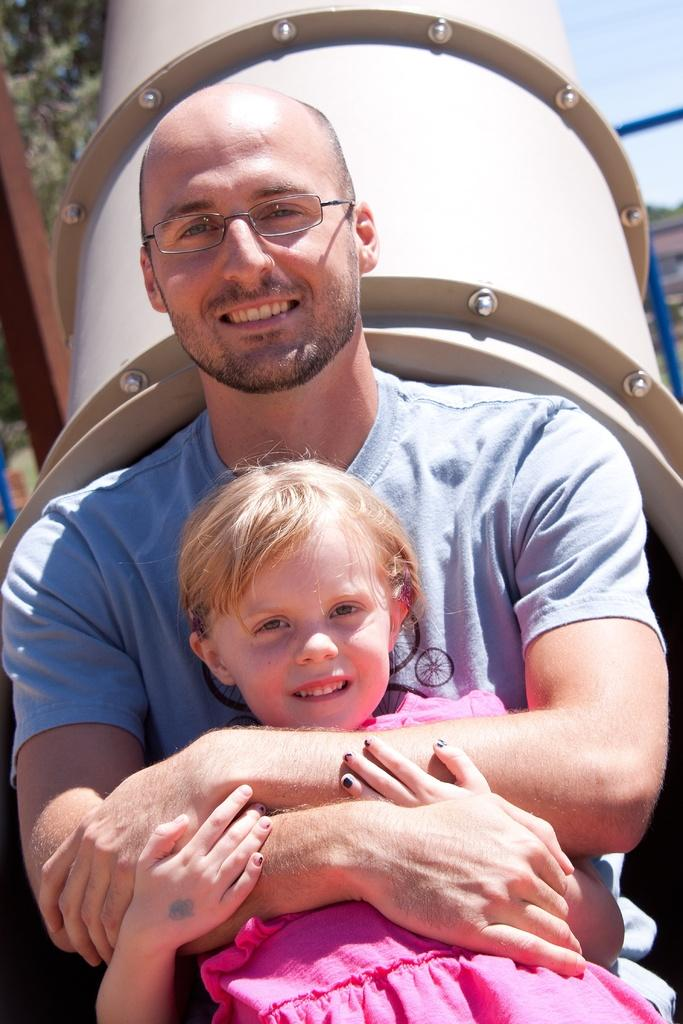Who are the people in the image? There is a man and a girl in the image. What are the man and girl doing in the image? The man and girl are watching and smiling in the image. How is the man interacting with the girl? The man is holding the girl in the image. What can be seen in the background of the image? There is a pipe, rods, trees, and the sky visible in the background of the image. What is the name of the insurance company mentioned in the image? There is no mention of an insurance company in the image. What impulse caused the man to suddenly jump in the image? There is no sudden jump or impulse mentioned in the image; the man and girl are simply watching and smiling. 